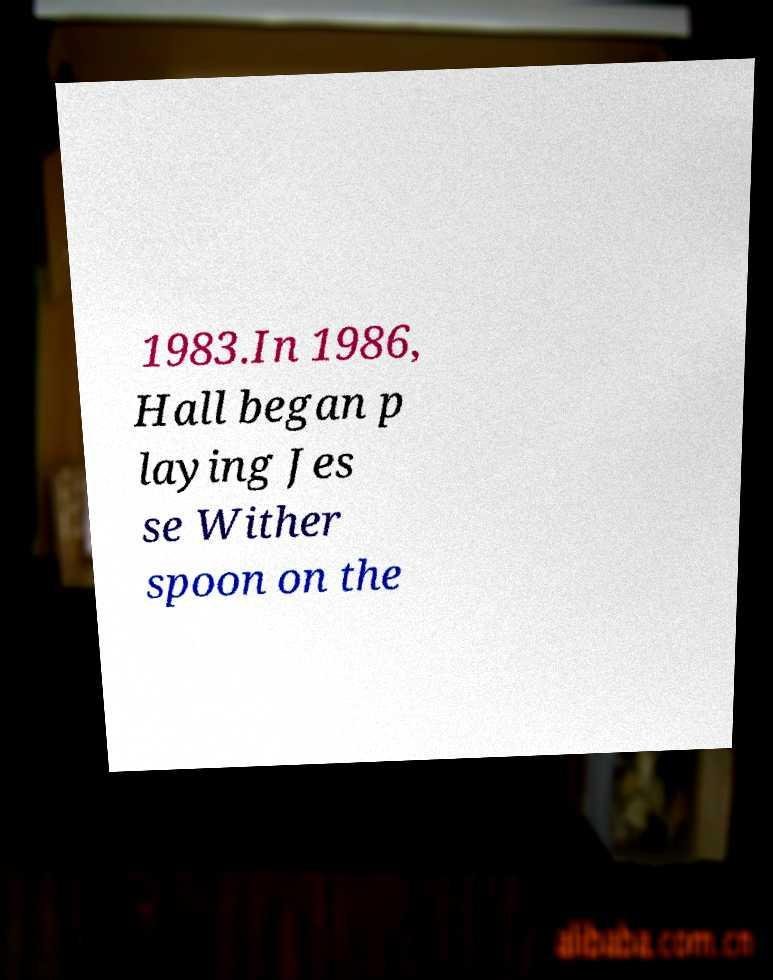Can you accurately transcribe the text from the provided image for me? 1983.In 1986, Hall began p laying Jes se Wither spoon on the 